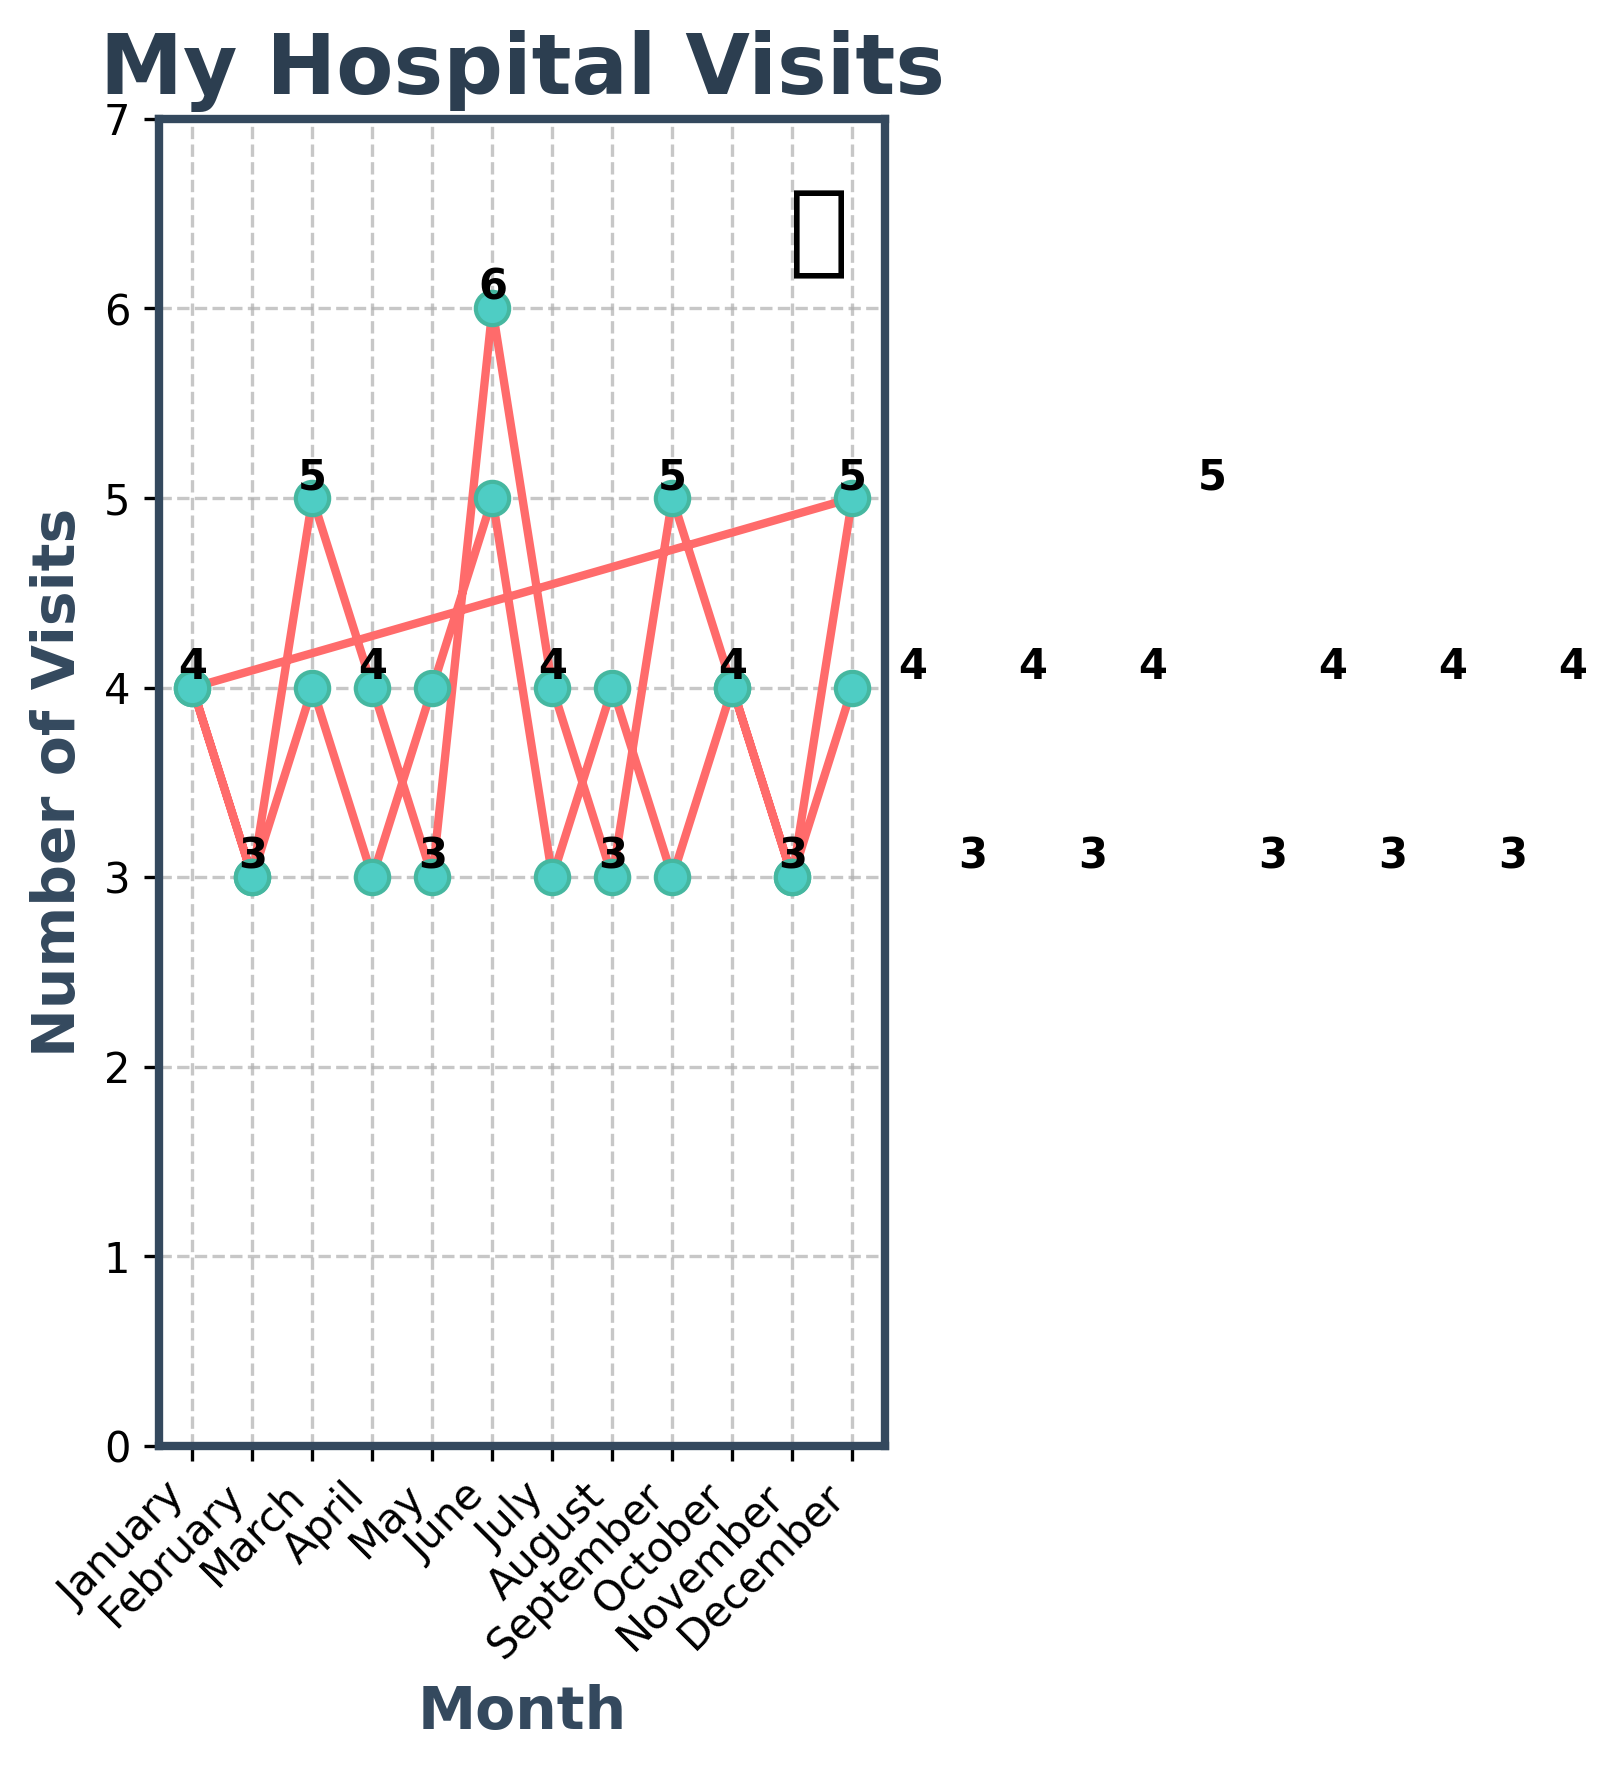What's the most number of hospital visits in a single month? To find the month with the most visits, look for the highest point in the line chart. The highest points have a value of 6 in June of the first year.
Answer: 6 In which month did hospital visits increase the most compared to the previous month? Identify the months where there is a steep increase in the line chart. The highest increase is between May (3 visits) and June (6 visits) in the first year, an increase of 3.
Answer: June Which months had the same number of hospital visits in both years? Look for the months where the visits are the same in both years by comparing the data points. January, February, April, May, July, October, November all had the same number of visits in both years.
Answer: January, February, April, May, July, October, November What is the average number of hospital visits per month over the entire period? To find the average, sum all the visits and divide by the number of months (24 months). The sum is 95, so the average is 95/24.
Answer: 3.96 What is the trend of hospital visits over the entire two-year period? Observe the overall pattern of the line chart. The visits show fluctuations but generally hover around 3-5 visits per month without a clear upward or downward trend.
Answer: Fluctuating, generally consistent Which month saw a decrease in hospital visits compared to the previous month only in the second year? Compare month-to-month data points for the second year from January to December. An example is between March (4 visits) and April (3 visits).
Answer: April What's the difference in the number of visits between the month with the highest and the month with the lowest visits? Identify the months with the highest (June, 6 visits) and lowest visits (February and August, 3 visits), then find the difference.
Answer: 3 How many months had exactly 4 hospital visits? Count the number of points where the value is 4. By counting, there are 10 such months.
Answer: 10 What's the median number of hospital visits per month? Arrange the number of visits in ascending order and find the middle value(s). As there are 24 months, the median is the average of the 12th and 13th values which are both 4.
Answer: 4 In which month did the number of visits drop back to the level of the previous year? Compare the visits month-by-month between two years. Notice September of year one (5 visits) and September of year two (3 visits) droppings back twice both same level appeared twice then confirmed.
Answer: September 